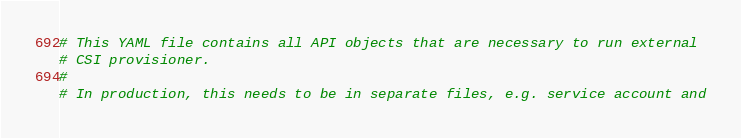Convert code to text. <code><loc_0><loc_0><loc_500><loc_500><_YAML_># This YAML file contains all API objects that are necessary to run external
# CSI provisioner.
#
# In production, this needs to be in separate files, e.g. service account and</code> 